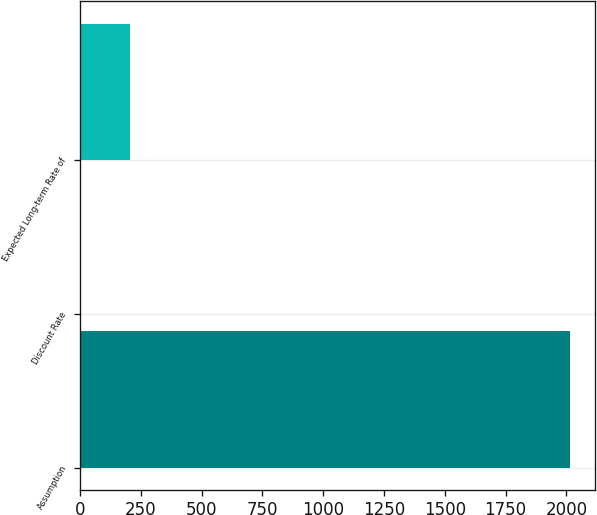Convert chart to OTSL. <chart><loc_0><loc_0><loc_500><loc_500><bar_chart><fcel>Assumption<fcel>Discount Rate<fcel>Expected Long-term Rate of<nl><fcel>2015<fcel>4.3<fcel>205.37<nl></chart> 